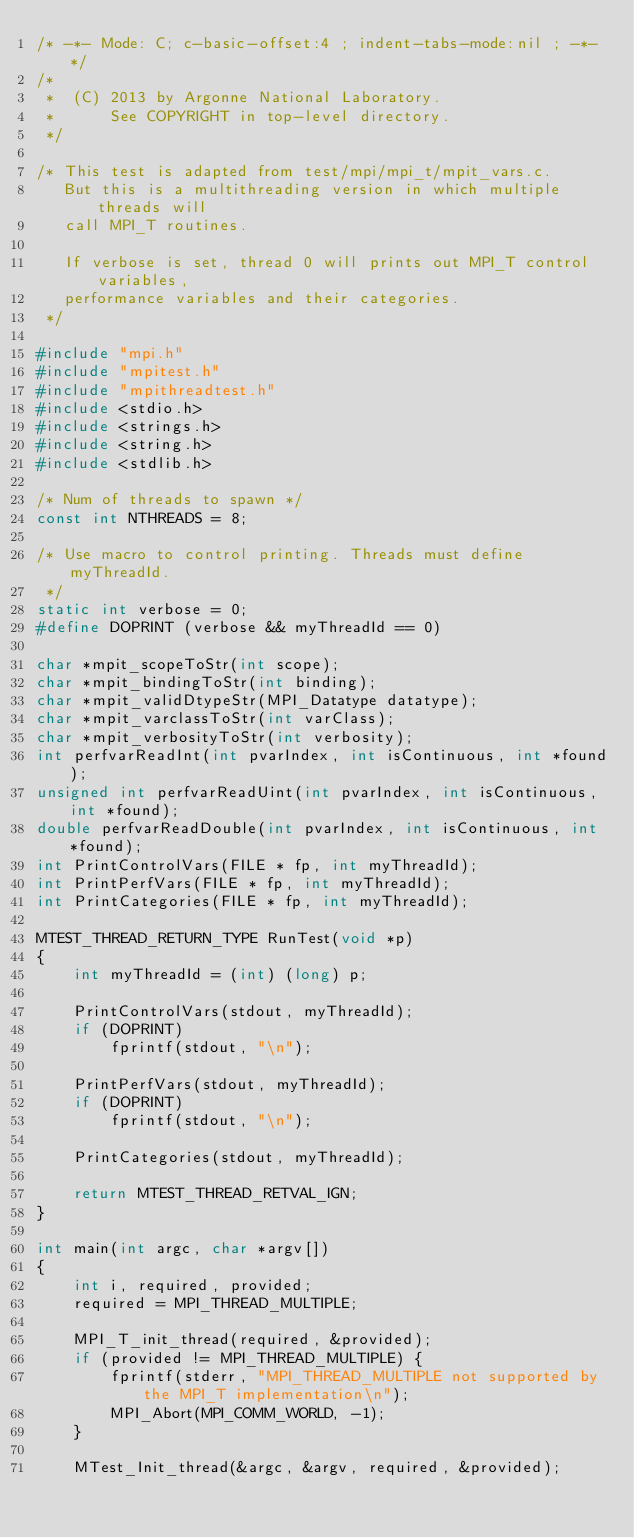<code> <loc_0><loc_0><loc_500><loc_500><_C_>/* -*- Mode: C; c-basic-offset:4 ; indent-tabs-mode:nil ; -*- */
/*
 *  (C) 2013 by Argonne National Laboratory.
 *      See COPYRIGHT in top-level directory.
 */

/* This test is adapted from test/mpi/mpi_t/mpit_vars.c.
   But this is a multithreading version in which multiple threads will
   call MPI_T routines.

   If verbose is set, thread 0 will prints out MPI_T control variables,
   performance variables and their categories.
 */

#include "mpi.h"
#include "mpitest.h"
#include "mpithreadtest.h"
#include <stdio.h>
#include <strings.h>
#include <string.h>
#include <stdlib.h>

/* Num of threads to spawn */
const int NTHREADS = 8;

/* Use macro to control printing. Threads must define myThreadId.
 */
static int verbose = 0;
#define DOPRINT (verbose && myThreadId == 0)

char *mpit_scopeToStr(int scope);
char *mpit_bindingToStr(int binding);
char *mpit_validDtypeStr(MPI_Datatype datatype);
char *mpit_varclassToStr(int varClass);
char *mpit_verbosityToStr(int verbosity);
int perfvarReadInt(int pvarIndex, int isContinuous, int *found);
unsigned int perfvarReadUint(int pvarIndex, int isContinuous, int *found);
double perfvarReadDouble(int pvarIndex, int isContinuous, int *found);
int PrintControlVars(FILE * fp, int myThreadId);
int PrintPerfVars(FILE * fp, int myThreadId);
int PrintCategories(FILE * fp, int myThreadId);

MTEST_THREAD_RETURN_TYPE RunTest(void *p)
{
    int myThreadId = (int) (long) p;

    PrintControlVars(stdout, myThreadId);
    if (DOPRINT)
        fprintf(stdout, "\n");

    PrintPerfVars(stdout, myThreadId);
    if (DOPRINT)
        fprintf(stdout, "\n");

    PrintCategories(stdout, myThreadId);

    return MTEST_THREAD_RETVAL_IGN;
}

int main(int argc, char *argv[])
{
    int i, required, provided;
    required = MPI_THREAD_MULTIPLE;

    MPI_T_init_thread(required, &provided);
    if (provided != MPI_THREAD_MULTIPLE) {
        fprintf(stderr, "MPI_THREAD_MULTIPLE not supported by the MPI_T implementation\n");
        MPI_Abort(MPI_COMM_WORLD, -1);
    }

    MTest_Init_thread(&argc, &argv, required, &provided);</code> 